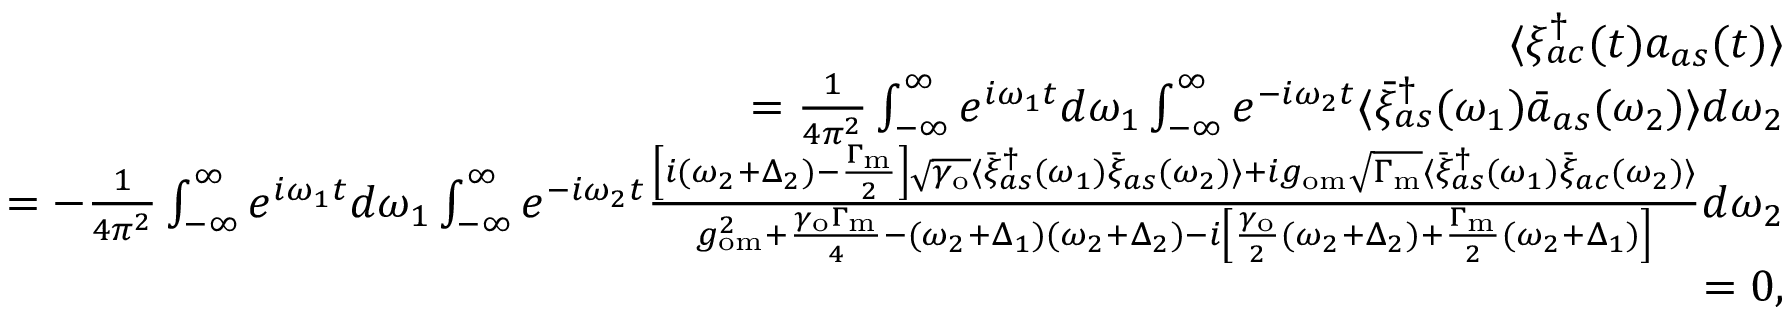Convert formula to latex. <formula><loc_0><loc_0><loc_500><loc_500>\begin{array} { r l r } & { \langle \xi _ { a c } ^ { \dagger } ( t ) a _ { a s } ( t ) \rangle } \\ & { = \frac { 1 } { 4 \pi ^ { 2 } } \int _ { - \infty } ^ { \infty } e ^ { i \omega _ { 1 } t } d \omega _ { 1 } \int _ { - \infty } ^ { \infty } e ^ { - i \omega _ { 2 } t } \langle \bar { \xi } _ { a s } ^ { \dagger } ( \omega _ { 1 } ) \bar { a } _ { a s } ( \omega _ { 2 } ) \rangle d \omega _ { 2 } } \\ & { = - \frac { 1 } { 4 \pi ^ { 2 } } \int _ { - \infty } ^ { \infty } e ^ { i \omega _ { 1 } t } d \omega _ { 1 } \int _ { - \infty } ^ { \infty } e ^ { - i \omega _ { 2 } t } \frac { \left [ i ( \omega _ { 2 } + \Delta _ { 2 } ) - \frac { \Gamma _ { m } } { 2 } \right ] \sqrt { \gamma _ { o } } \langle \bar { \xi } _ { a s } ^ { \dagger } ( \omega _ { 1 } ) \bar { \xi } _ { a s } ( \omega _ { 2 } ) \rangle + i g _ { o m } \sqrt { \Gamma _ { m } } \langle \bar { \xi } _ { a s } ^ { \dagger } ( \omega _ { 1 } ) \bar { \xi } _ { a c } ( \omega _ { 2 } ) \rangle } { g _ { o m } ^ { 2 } + \frac { \gamma _ { o } \Gamma _ { m } } { 4 } - ( \omega _ { 2 } + \Delta _ { 1 } ) ( \omega _ { 2 } + \Delta _ { 2 } ) - i \left [ \frac { \gamma _ { o } } { 2 } ( \omega _ { 2 } + \Delta _ { 2 } ) + \frac { \Gamma _ { m } } { 2 } ( \omega _ { 2 } + \Delta _ { 1 } ) \right ] } d \omega _ { 2 } } \\ & { = 0 , } \end{array}</formula> 